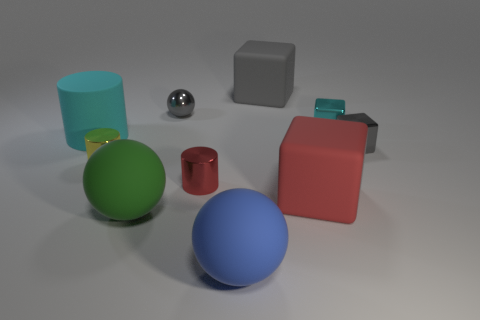Subtract all matte spheres. How many spheres are left? 1 Subtract all blue balls. How many balls are left? 2 Subtract 4 blocks. How many blocks are left? 0 Subtract all spheres. How many objects are left? 7 Subtract all red cylinders. How many cyan blocks are left? 1 Subtract 1 blue balls. How many objects are left? 9 Subtract all red cylinders. Subtract all brown balls. How many cylinders are left? 2 Subtract all small green matte balls. Subtract all large cylinders. How many objects are left? 9 Add 5 tiny red cylinders. How many tiny red cylinders are left? 6 Add 6 big cubes. How many big cubes exist? 8 